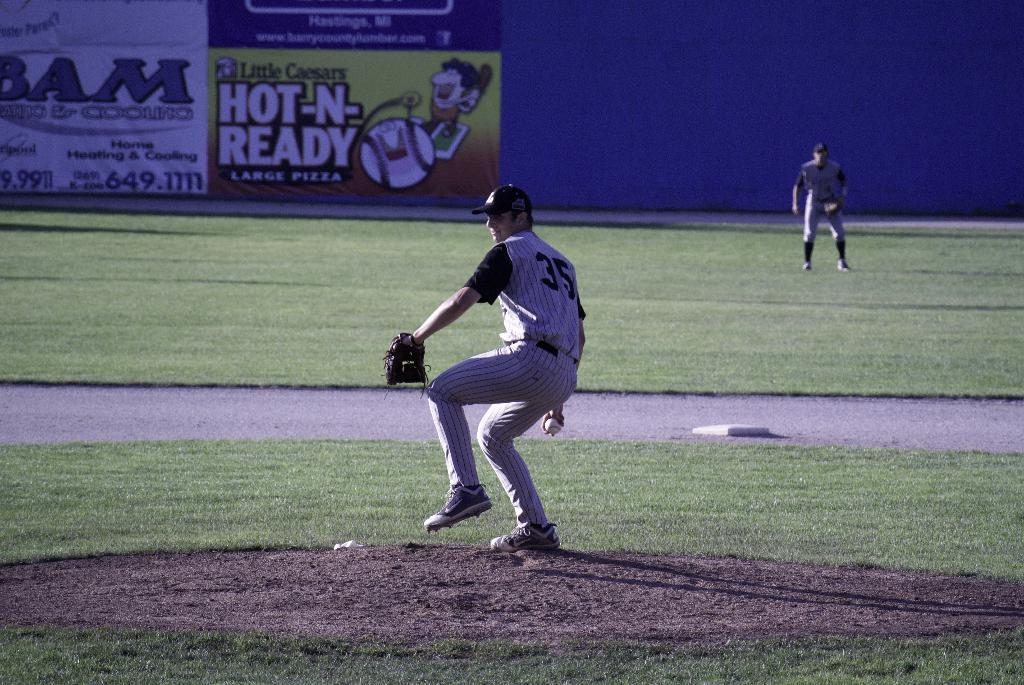What is the main subject of the image? The main subject of the image is a playground. How many people are in the image? There are two persons in the image. What is the purpose of the fence in the image? The fence is present to provide a boundary around the playground and include additional elements like a cartoon picture and text. Can you see a boat in the image? There is no boat present in the image. What type of zipper is featured on the cartoon character on the fence? There is no zipper present in the image; the cartoon character on the fence does not have any clothing or accessories that would include a zipper. 